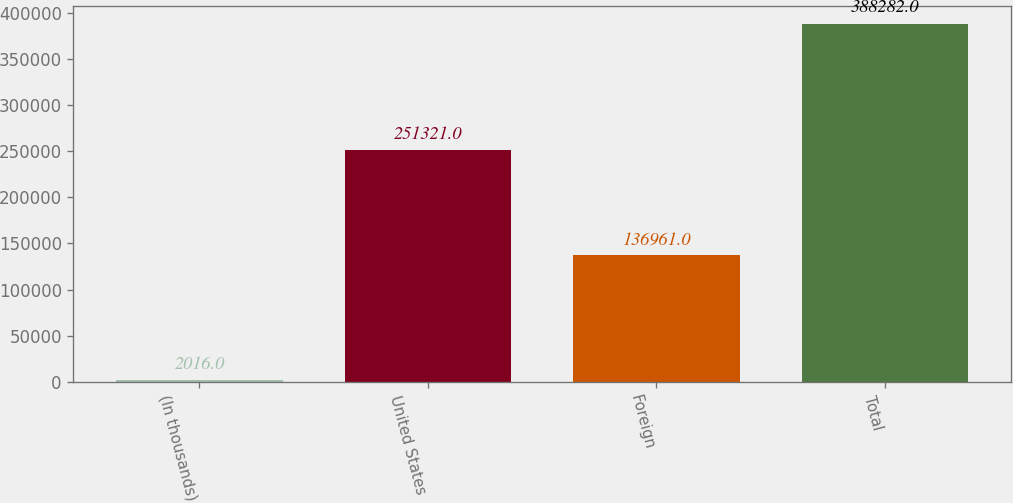Convert chart to OTSL. <chart><loc_0><loc_0><loc_500><loc_500><bar_chart><fcel>(In thousands)<fcel>United States<fcel>Foreign<fcel>Total<nl><fcel>2016<fcel>251321<fcel>136961<fcel>388282<nl></chart> 